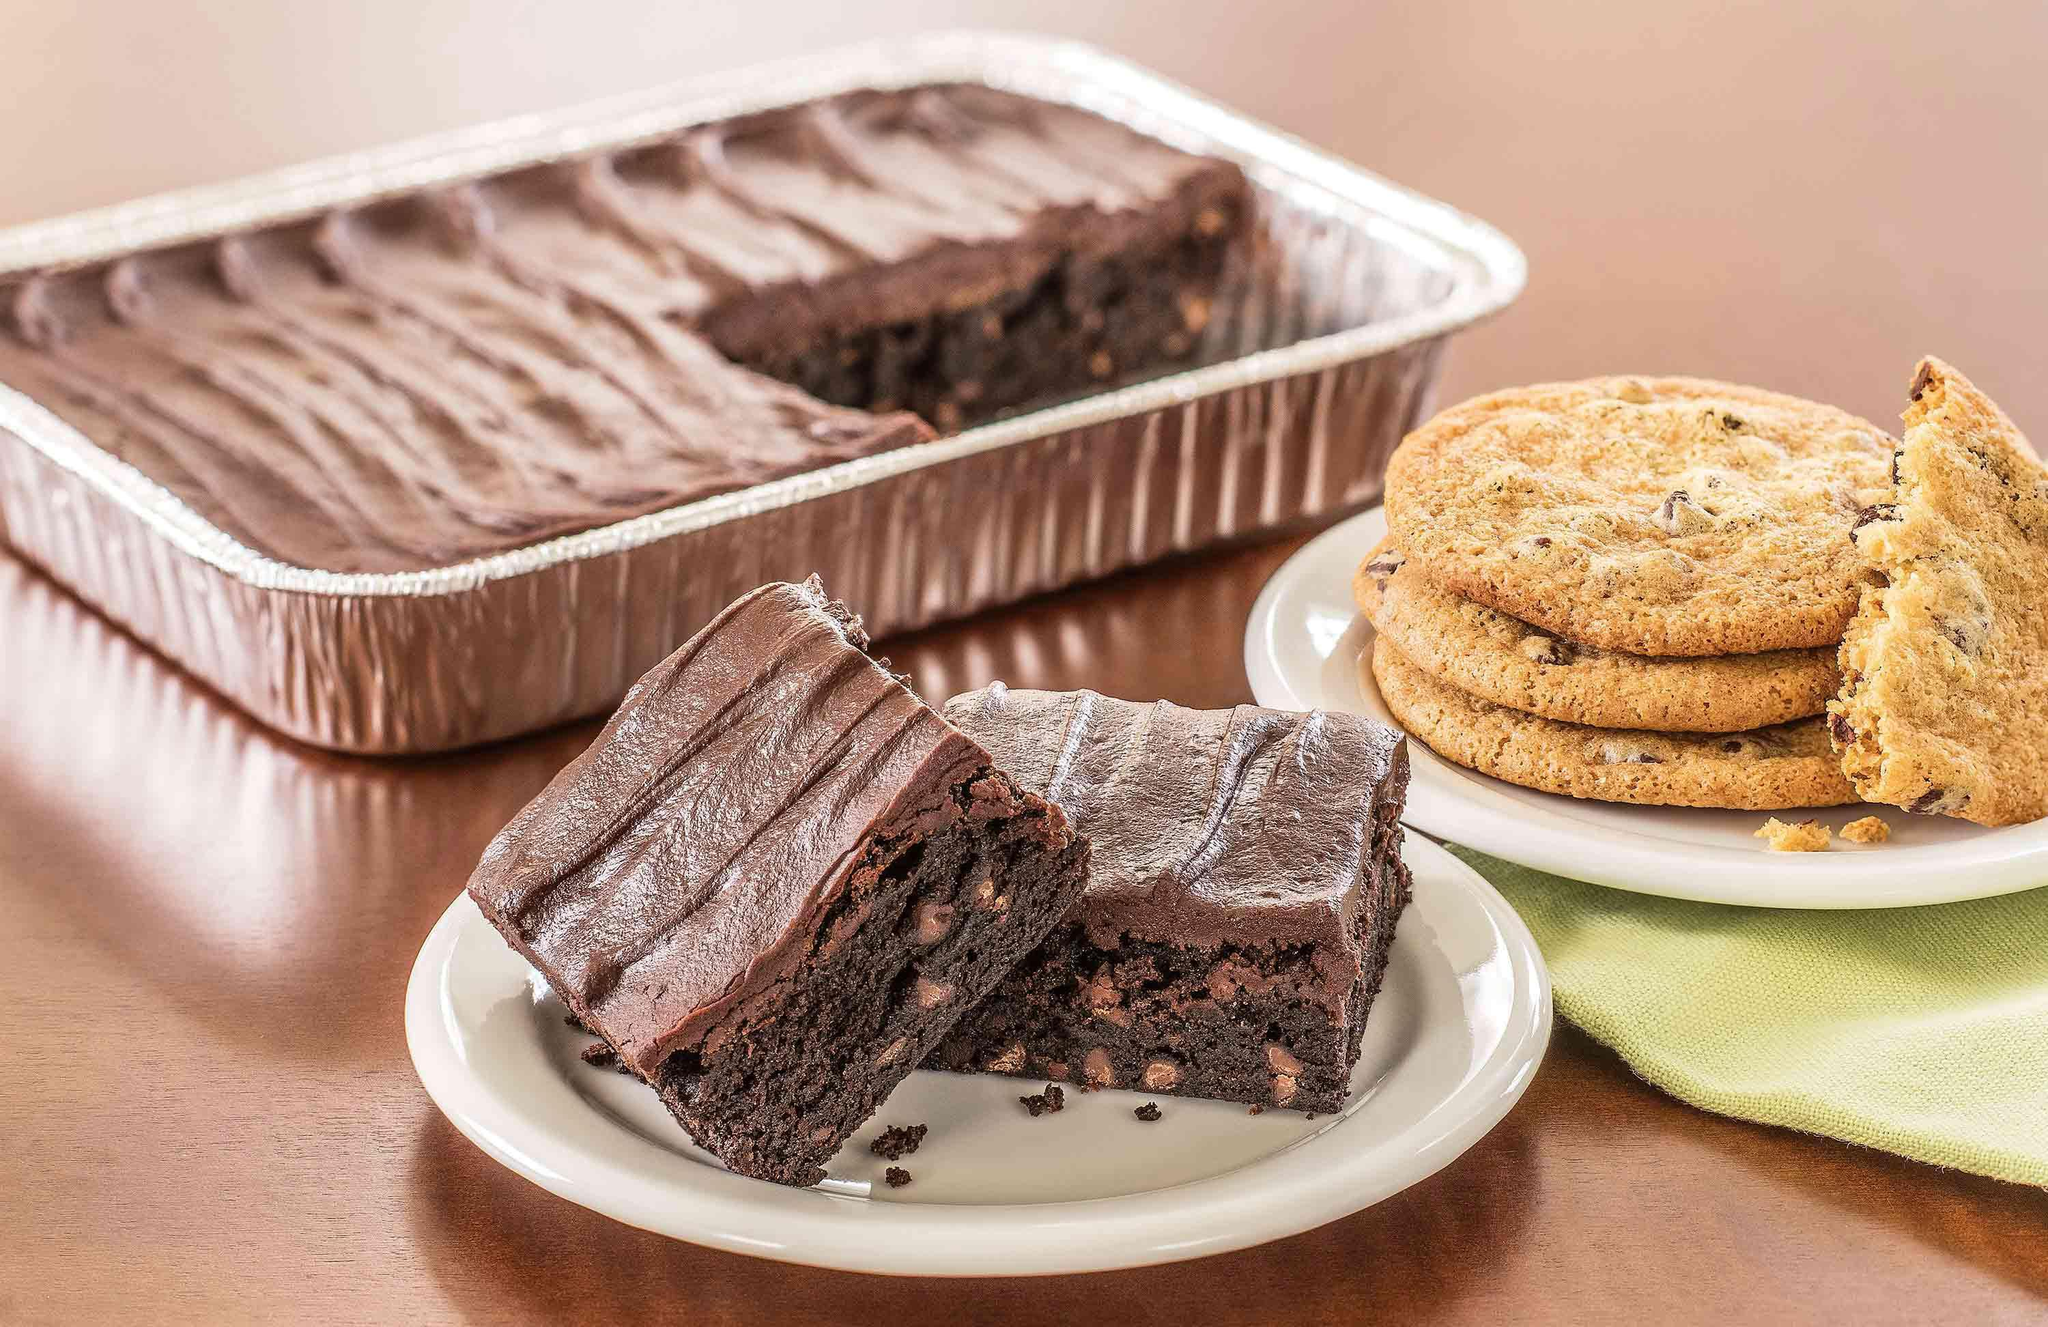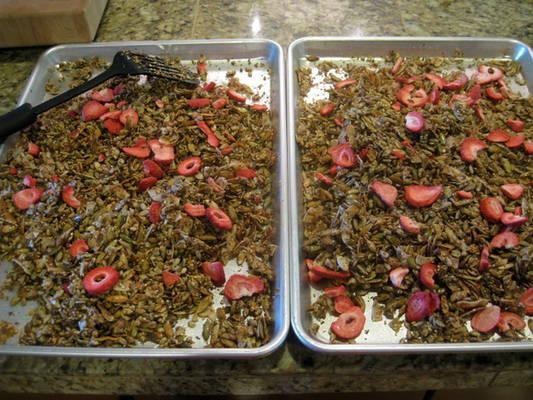The first image is the image on the left, the second image is the image on the right. Assess this claim about the two images: "At least one photo shows a menu that is hand-written and a variety of sweets on pedestals of different heights.". Correct or not? Answer yes or no. No. 